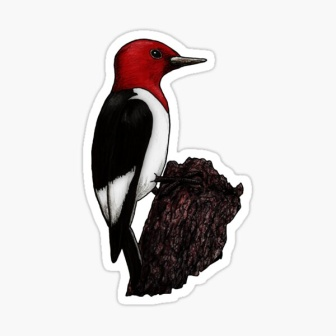Can you elaborate on the elements of the picture provided? The image captures a detailed and vibrant portrayal of a red-headed woodpecker. This bird is marked by its striking red head that contrasts sharply with its white chest and black wings. It is perched on a ruggedly textured dark brown tree stump. The stump has a small branch protruding from it, enhancing the natural setting of the scene. The entire composition is framed by a white border, giving the appearance of a sticker. The vivid colors of the woodpecker make it stand out as the central focus of the image, while the harmonious balance between the bird and the tree stump creates a pleasing visual aesthetic. This composition effectively brings out the beauty and intricacies of the natural world. 